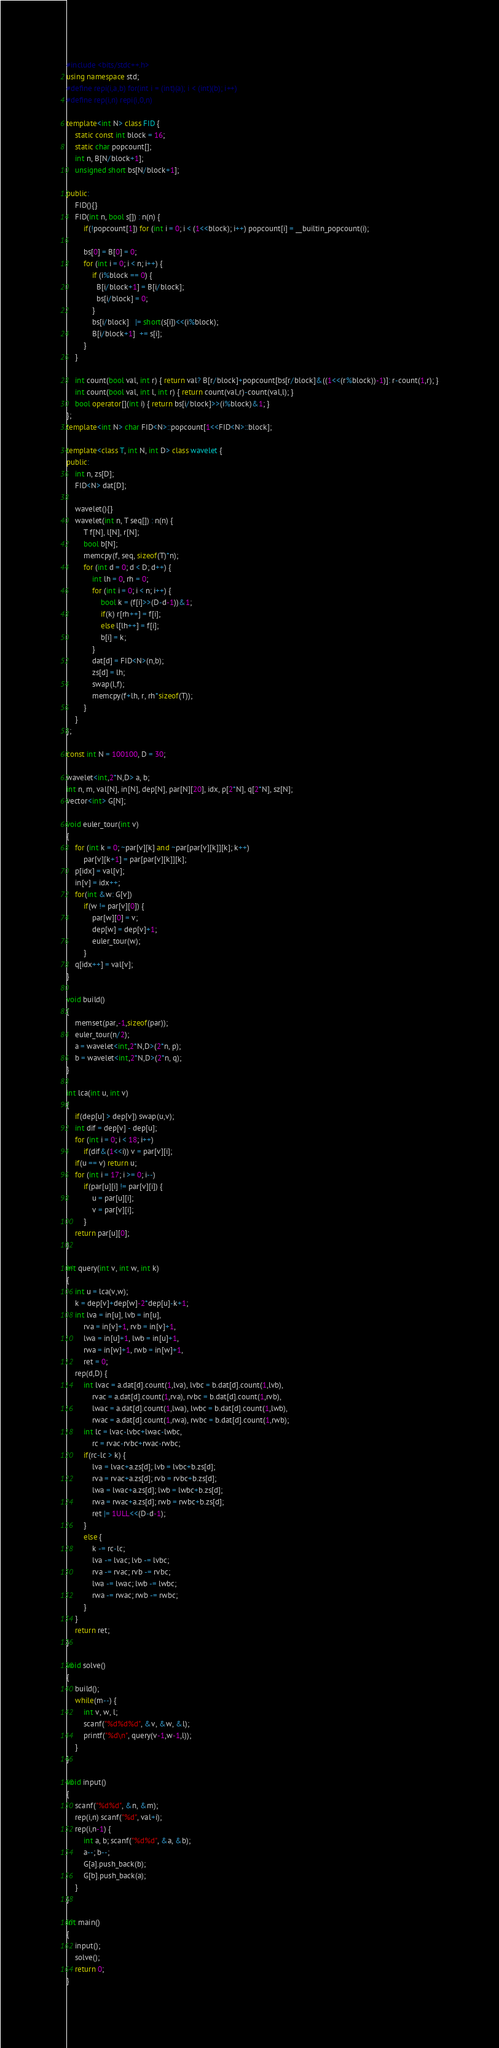<code> <loc_0><loc_0><loc_500><loc_500><_C++_>#include <bits/stdc++.h>
using namespace std;
#define repi(i,a,b) for(int i = (int)(a); i < (int)(b); i++)
#define rep(i,n) repi(i,0,n)

template<int N> class FID {
    static const int block = 16;
    static char popcount[];
    int n, B[N/block+1];
    unsigned short bs[N/block+1];

public:
    FID(){}
    FID(int n, bool s[]) : n(n) {
        if(!popcount[1]) for (int i = 0; i < (1<<block); i++) popcount[i] = __builtin_popcount(i);

        bs[0] = B[0] = 0;
        for (int i = 0; i < n; i++) {
            if (i%block == 0) {
              B[i/block+1] = B[i/block];
              bs[i/block] = 0;
            }
            bs[i/block]   |= short(s[i])<<(i%block);
            B[i/block+1]  += s[i];
        }
    }

    int count(bool val, int r) { return val? B[r/block]+popcount[bs[r/block]&((1<<(r%block))-1)]: r-count(1,r); }
    int count(bool val, int l, int r) { return count(val,r)-count(val,l); }
    bool operator[](int i) { return bs[i/block]>>(i%block)&1; }
};
template<int N> char FID<N>::popcount[1<<FID<N>::block];

template<class T, int N, int D> class wavelet {
public:
    int n, zs[D];
    FID<N> dat[D];

    wavelet(){}
    wavelet(int n, T seq[]) : n(n) {
        T f[N], l[N], r[N];
        bool b[N];
        memcpy(f, seq, sizeof(T)*n);
        for (int d = 0; d < D; d++) {
            int lh = 0, rh = 0;
            for (int i = 0; i < n; i++) {
                bool k = (f[i]>>(D-d-1))&1;
                if(k) r[rh++] = f[i];
                else l[lh++] = f[i];
                b[i] = k;
            }
            dat[d] = FID<N>(n,b);
            zs[d] = lh;
            swap(l,f);
            memcpy(f+lh, r, rh*sizeof(T));
        }
    }
};

const int N = 100100, D = 30;

wavelet<int,2*N,D> a, b;
int n, m, val[N], in[N], dep[N], par[N][20], idx, p[2*N], q[2*N], sz[N];
vector<int> G[N];

void euler_tour(int v)
{
    for (int k = 0; ~par[v][k] and ~par[par[v][k]][k]; k++)
        par[v][k+1] = par[par[v][k]][k];
    p[idx] = val[v];
    in[v] = idx++;
    for(int &w: G[v])
        if(w != par[v][0]) {
            par[w][0] = v;
            dep[w] = dep[v]+1;
            euler_tour(w);
        }
    q[idx++] = val[v];
}

void build()
{
    memset(par,-1,sizeof(par));
    euler_tour(n/2);
    a = wavelet<int,2*N,D>(2*n, p);
    b = wavelet<int,2*N,D>(2*n, q);
}

int lca(int u, int v)
{
    if(dep[u] > dep[v]) swap(u,v);
    int dif = dep[v] - dep[u];
    for (int i = 0; i < 18; i++)
        if(dif&(1<<i)) v = par[v][i];
    if(u == v) return u;
    for (int i = 17; i >= 0; i--)
        if(par[u][i] != par[v][i]) {
            u = par[u][i];
            v = par[v][i];
        }
    return par[u][0];
}

int query(int v, int w, int k)
{
    int u = lca(v,w);
    k = dep[v]+dep[w]-2*dep[u]-k+1;
    int lva = in[u], lvb = in[u],
        rva = in[v]+1, rvb = in[v]+1,
        lwa = in[u]+1, lwb = in[u]+1,
        rwa = in[w]+1, rwb = in[w]+1,
        ret = 0;
    rep(d,D) {
        int lvac = a.dat[d].count(1,lva), lvbc = b.dat[d].count(1,lvb),
            rvac = a.dat[d].count(1,rva), rvbc = b.dat[d].count(1,rvb),
            lwac = a.dat[d].count(1,lwa), lwbc = b.dat[d].count(1,lwb),
            rwac = a.dat[d].count(1,rwa), rwbc = b.dat[d].count(1,rwb);
        int lc = lvac-lvbc+lwac-lwbc,
            rc = rvac-rvbc+rwac-rwbc;
        if(rc-lc > k) {
            lva = lvac+a.zs[d]; lvb = lvbc+b.zs[d];
            rva = rvac+a.zs[d]; rvb = rvbc+b.zs[d];
            lwa = lwac+a.zs[d]; lwb = lwbc+b.zs[d];
            rwa = rwac+a.zs[d]; rwb = rwbc+b.zs[d];
            ret |= 1ULL<<(D-d-1);
        }
        else {
            k -= rc-lc;
            lva -= lvac; lvb -= lvbc;
            rva -= rvac; rvb -= rvbc;
            lwa -= lwac; lwb -= lwbc;
            rwa -= rwac; rwb -= rwbc;
        }
    }
    return ret;
}

void solve()
{
    build();
    while(m--) {
        int v, w, l;
        scanf("%d%d%d", &v, &w, &l);
        printf("%d\n", query(v-1,w-1,l));
    }
}

void input()
{
    scanf("%d%d", &n, &m);
    rep(i,n) scanf("%d", val+i);
    rep(i,n-1) {
        int a, b; scanf("%d%d", &a, &b);
        a--; b--;
        G[a].push_back(b);
        G[b].push_back(a);
    }
}

int main()
{
    input();
    solve();
    return 0;
}

</code> 